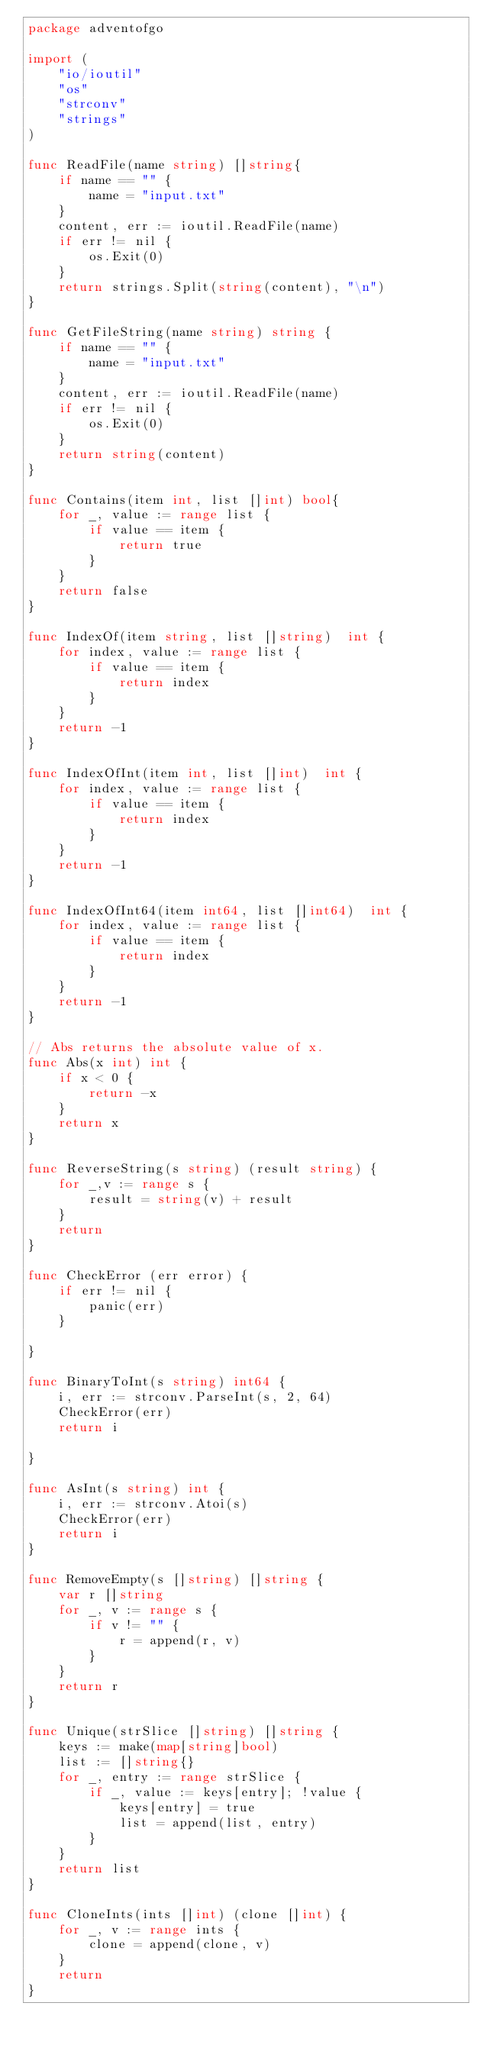<code> <loc_0><loc_0><loc_500><loc_500><_Go_>package adventofgo

import (
	"io/ioutil"
	"os"
	"strconv"
	"strings"
)

func ReadFile(name string) []string{
	if name == "" {
		name = "input.txt"
	}
	content, err := ioutil.ReadFile(name)
	if err != nil {
		os.Exit(0)
	}
	return strings.Split(string(content), "\n")
}

func GetFileString(name string) string {
	if name == "" {
		name = "input.txt"
	}
	content, err := ioutil.ReadFile(name)
	if err != nil {
		os.Exit(0)
	}
	return string(content)
}

func Contains(item int, list []int) bool{
	for _, value := range list {
		if value == item {
			return true
		}
	}
	return false
}

func IndexOf(item string, list []string)  int {
	for index, value := range list {
		if value == item {
			return index
		}
	}
	return -1
}

func IndexOfInt(item int, list []int)  int {
	for index, value := range list {
		if value == item {
			return index
		}
	}
	return -1
}

func IndexOfInt64(item int64, list []int64)  int {
	for index, value := range list {
		if value == item {
			return index
		}
	}
	return -1
}

// Abs returns the absolute value of x.
func Abs(x int) int {
	if x < 0 {
		return -x
	}
	return x
}

func ReverseString(s string) (result string) {
	for _,v := range s {
		result = string(v) + result
	}
	return
}

func CheckError (err error) {
	if err != nil {
		panic(err)
	}

}

func BinaryToInt(s string) int64 {
	i, err := strconv.ParseInt(s, 2, 64)
	CheckError(err)
	return i

}

func AsInt(s string) int {
	i, err := strconv.Atoi(s)
	CheckError(err)
	return i
}

func RemoveEmpty(s []string) []string {
	var r []string
	for _, v := range s {
		if v != "" {
			r = append(r, v)
		}
	}
	return r
}

func Unique(strSlice []string) []string {
	keys := make(map[string]bool)
	list := []string{}
	for _, entry := range strSlice {
		if _, value := keys[entry]; !value {
			keys[entry] = true
			list = append(list, entry)
		}
	}
	return list
}

func CloneInts(ints []int) (clone []int) {
	for _, v := range ints {
		clone = append(clone, v)
	}
	return
}</code> 